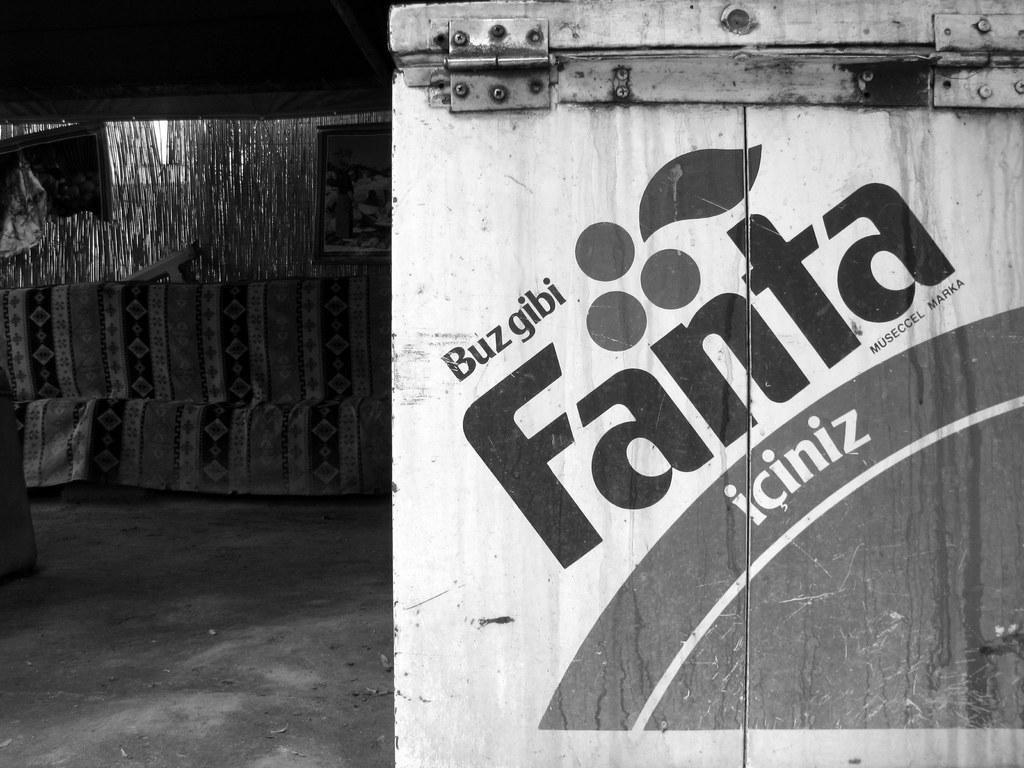How would you summarize this image in a sentence or two? In this image we can see a box on which it is written as fanta and in the background of the image there are some more items. 